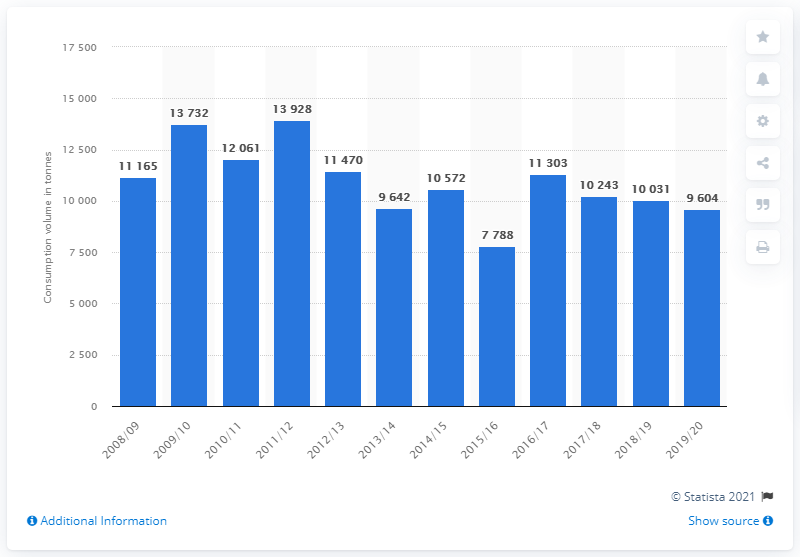Indicate a few pertinent items in this graphic. In 2016/17, Austria's beetroot consumption was 11,303 metric tons. In 2019/20, approximately 9,604 metric tons of beetroots were consumed in Austria. 